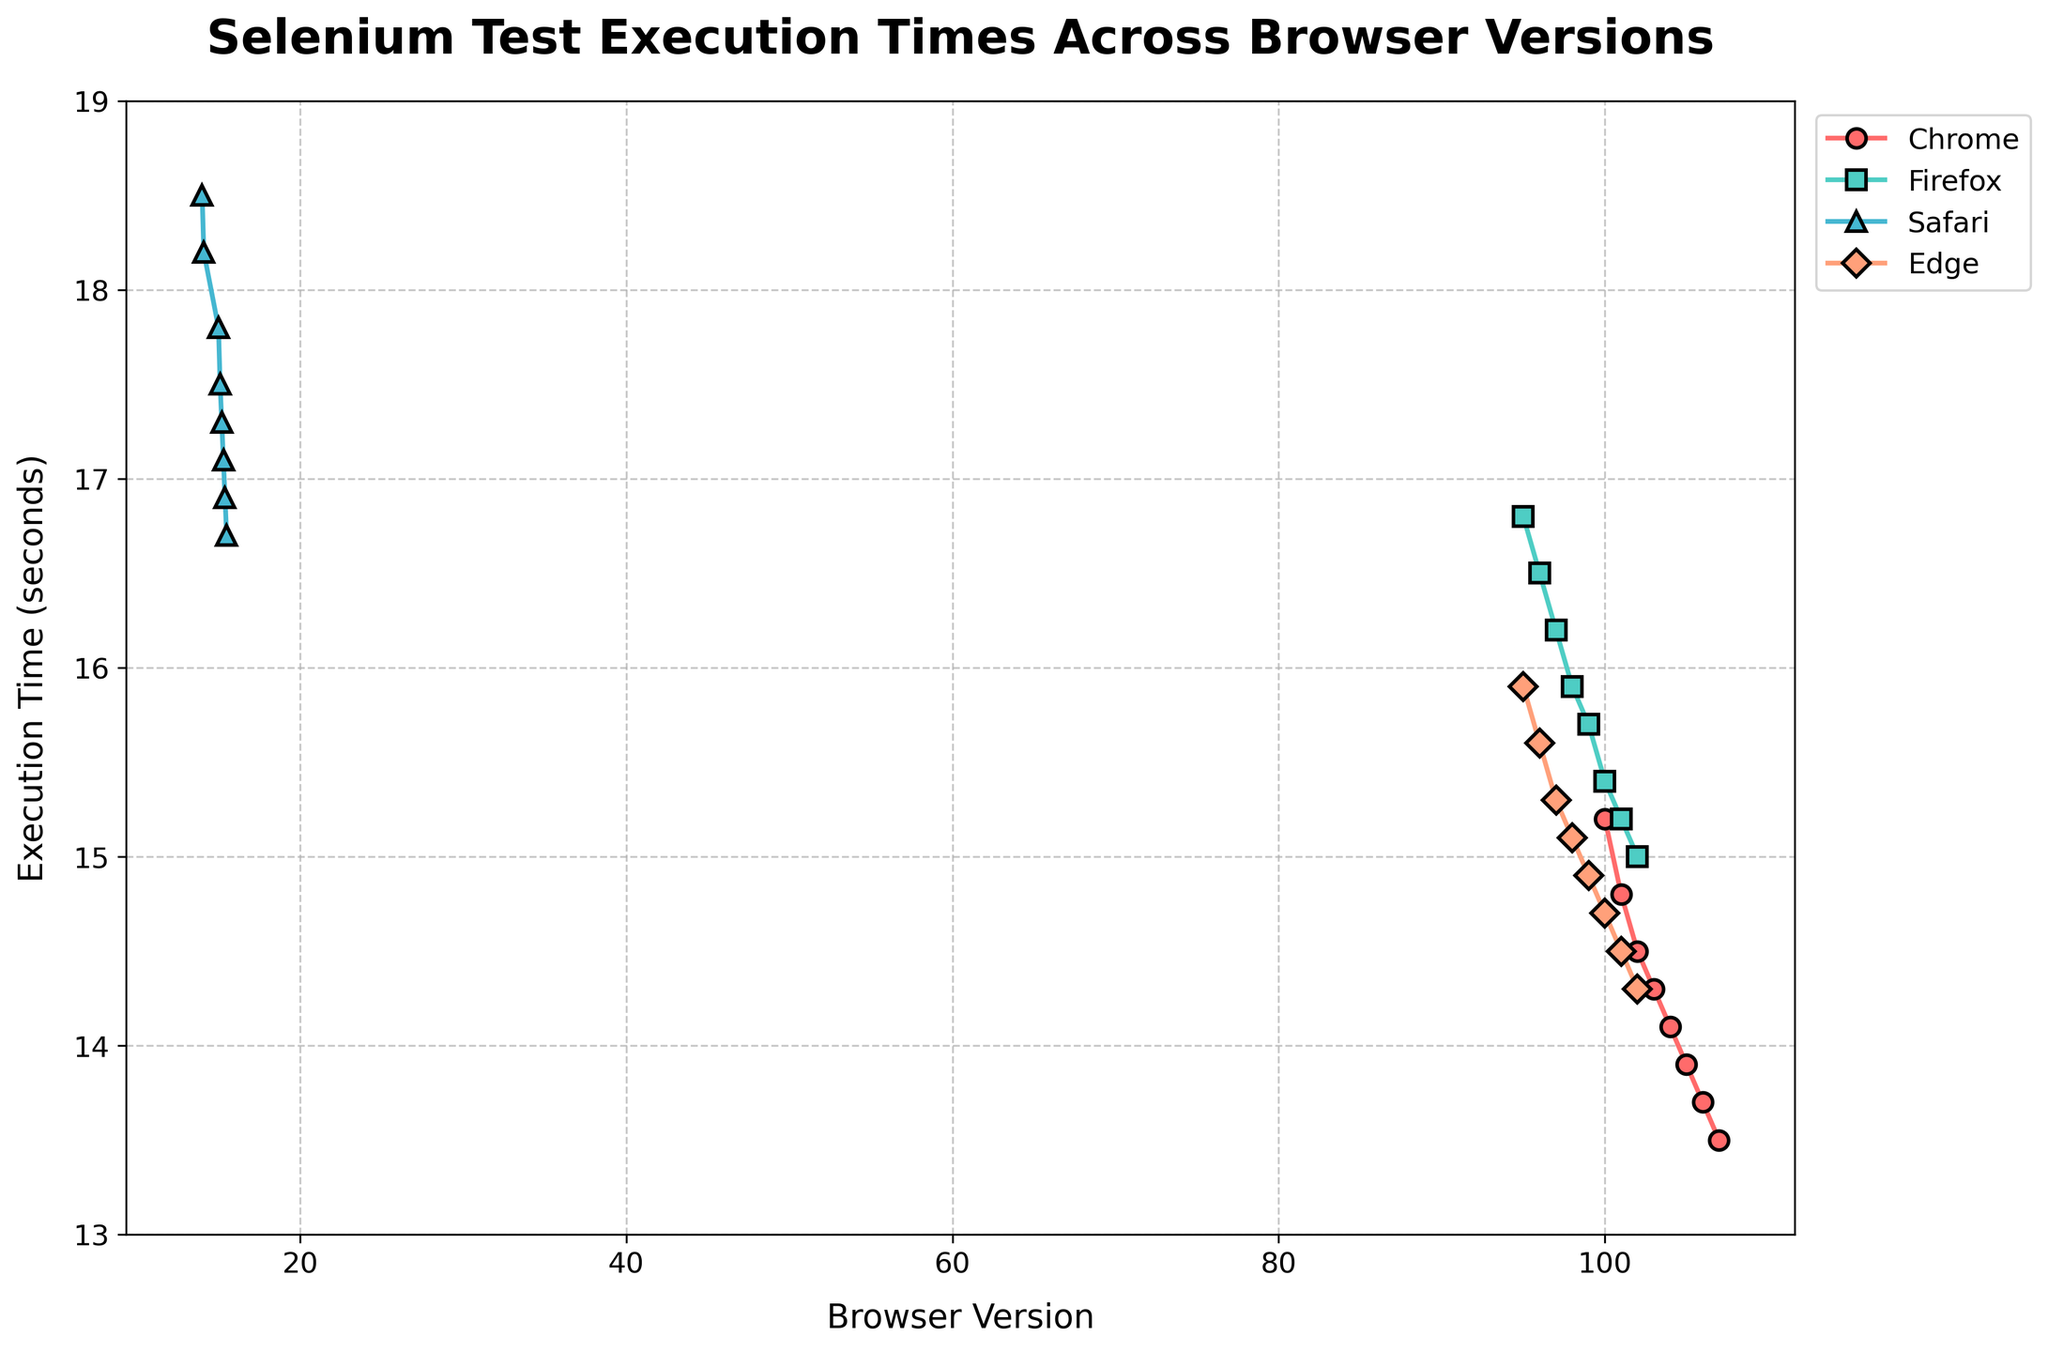What's the trend of execution times for Chrome across its versions? If you trace the line for Chrome shown in the plot, you can see a general decreasing trend from version 100 to 107.
Answer: Decreasing How does the execution time of Firefox version 102 compare to Chrome version 102? By looking at the y-axis values for the points where Firefox and Chrome's execution times meet version 102, you can see that Firefox's execution time is 15.0 seconds, while Chrome's is 14.5 seconds.
Answer: Firefox's is longer Which browser generally has the highest execution times? By comparing the lines for each browser, Safari consistently has the highest points (highest y-axis values).
Answer: Safari What is the difference in execution time between Safari version 14 and version 15.5? For Safari, the execution time at version 14 is 18.5 seconds and at 15.5 is 16.7 seconds. The difference is 18.5 - 16.7 = 1.8 seconds.
Answer: 1.8 seconds Which browser shows the most significant decrease in execution time over the plotted versions? By examining the slope of lines for each browser, Chrome shows a significant decrease from its starting point at version 100 to its endpoint at version 107.
Answer: Chrome What are the execution times for Edge across the versions 95 to 102? The plot shows Edge having execution times of 15.9, 15.6, 15.3, 15.1, 14.9, 14.7, 14.5, and 14.3 seconds from version 95 to 102 respectively.
Answer: 15.9, 15.6, 15.3, 15.1, 14.9, 14.7, 14.5, 14.3 Between Firefox and Safari, which browser shows a more significant rate of decrease in execution time? Comparing the slopes of the lines for Firefox and Safari, Firefox shows a more pronounced decline as its line's slope is steeper from version 95 to 102.
Answer: Firefox Do the execution times for any browsers intersect at any versions? Looking at the plotted lines, none of the browser execution times intersect at any versions from the given data.
Answer: No What is the execution time trend for Edge, and how does it compare to the trend of Chrome? Both Edge and Chrome show a consistent decreasing trend over their respective versions, with Chrome having a slightly steeper decrease than Edge.
Answer: Both decreasing; Chrome's decrease is steeper Which browser's execution time remains above 16 seconds for all versions? Safari's execution time, as seen from the plot, stays above 16 seconds throughout all its versions.
Answer: Safari 